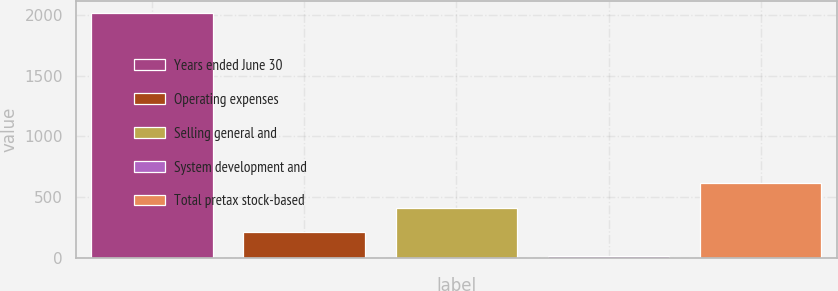<chart> <loc_0><loc_0><loc_500><loc_500><bar_chart><fcel>Years ended June 30<fcel>Operating expenses<fcel>Selling general and<fcel>System development and<fcel>Total pretax stock-based<nl><fcel>2013<fcel>214.35<fcel>414.2<fcel>14.5<fcel>614.05<nl></chart> 